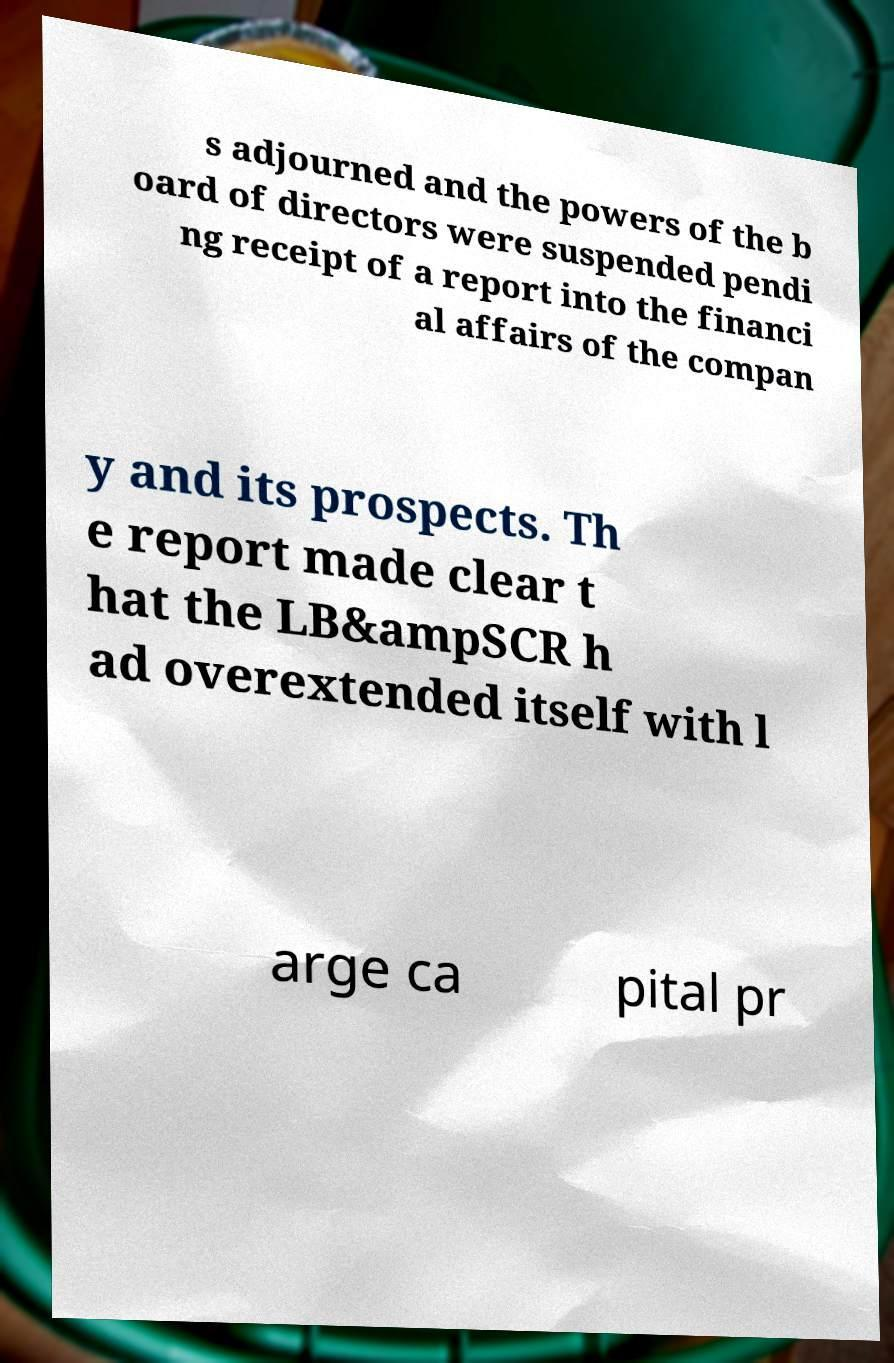I need the written content from this picture converted into text. Can you do that? s adjourned and the powers of the b oard of directors were suspended pendi ng receipt of a report into the financi al affairs of the compan y and its prospects. Th e report made clear t hat the LB&ampSCR h ad overextended itself with l arge ca pital pr 